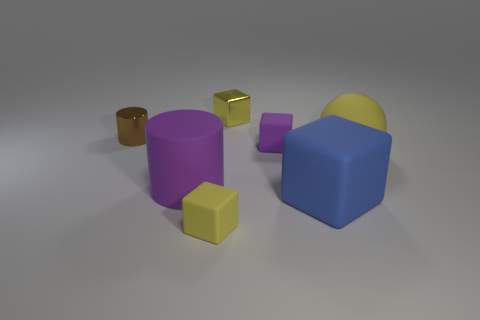What number of cylinders are rubber things or brown shiny objects?
Make the answer very short. 2. There is a tiny brown thing behind the large ball; what is its shape?
Your answer should be very brief. Cylinder. What color is the tiny rubber thing that is on the left side of the small yellow thing that is behind the small cube in front of the tiny purple cube?
Your response must be concise. Yellow. Does the big blue object have the same material as the brown cylinder?
Your answer should be very brief. No. How many red things are either matte objects or small shiny objects?
Your answer should be compact. 0. What number of big purple rubber cylinders are behind the brown shiny thing?
Give a very brief answer. 0. Are there more purple objects than rubber objects?
Keep it short and to the point. No. What shape is the tiny matte object that is in front of the big thing to the left of the large blue matte thing?
Keep it short and to the point. Cube. Is the matte ball the same color as the shiny block?
Make the answer very short. Yes. Is the number of matte things right of the purple rubber cube greater than the number of tiny yellow matte spheres?
Provide a succinct answer. Yes. 